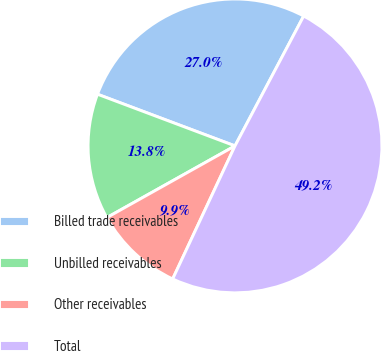Convert chart. <chart><loc_0><loc_0><loc_500><loc_500><pie_chart><fcel>Billed trade receivables<fcel>Unbilled receivables<fcel>Other receivables<fcel>Total<nl><fcel>27.02%<fcel>13.84%<fcel>9.91%<fcel>49.23%<nl></chart> 